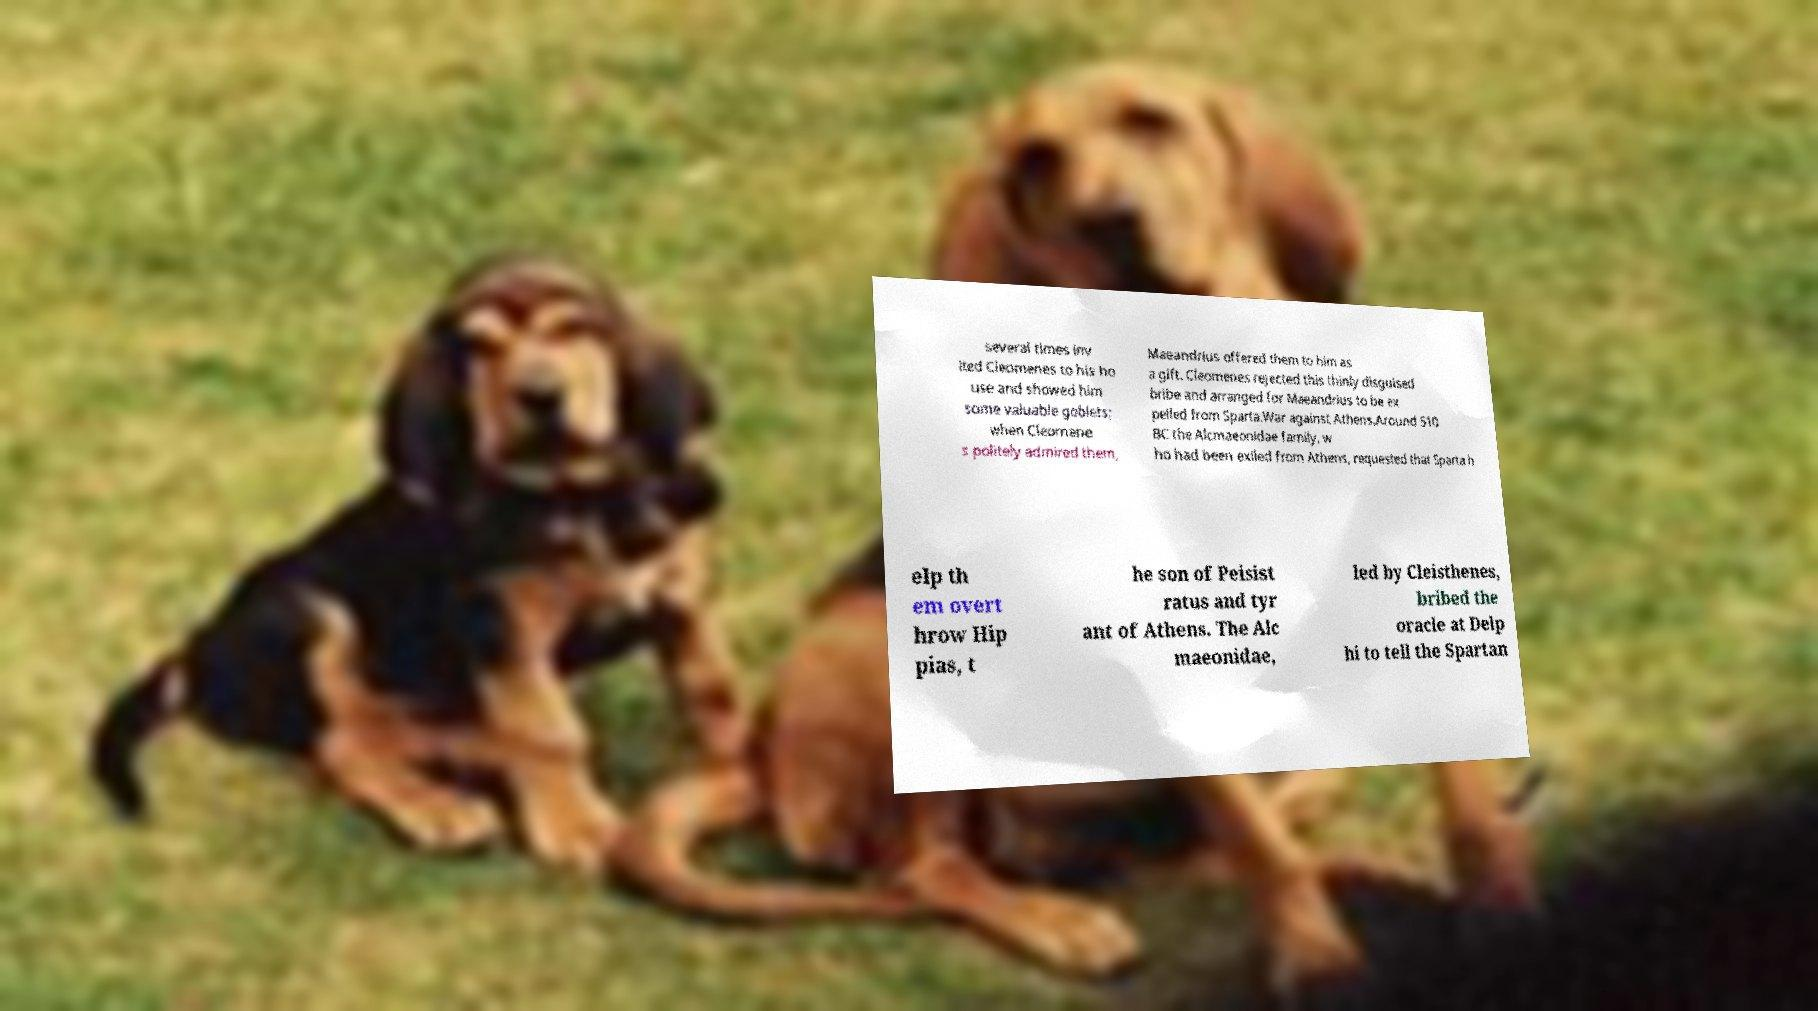For documentation purposes, I need the text within this image transcribed. Could you provide that? several times inv ited Cleomenes to his ho use and showed him some valuable goblets; when Cleomene s politely admired them, Maeandrius offered them to him as a gift. Cleomenes rejected this thinly disguised bribe and arranged for Maeandrius to be ex pelled from Sparta.War against Athens.Around 510 BC the Alcmaeonidae family, w ho had been exiled from Athens, requested that Sparta h elp th em overt hrow Hip pias, t he son of Peisist ratus and tyr ant of Athens. The Alc maeonidae, led by Cleisthenes, bribed the oracle at Delp hi to tell the Spartan 